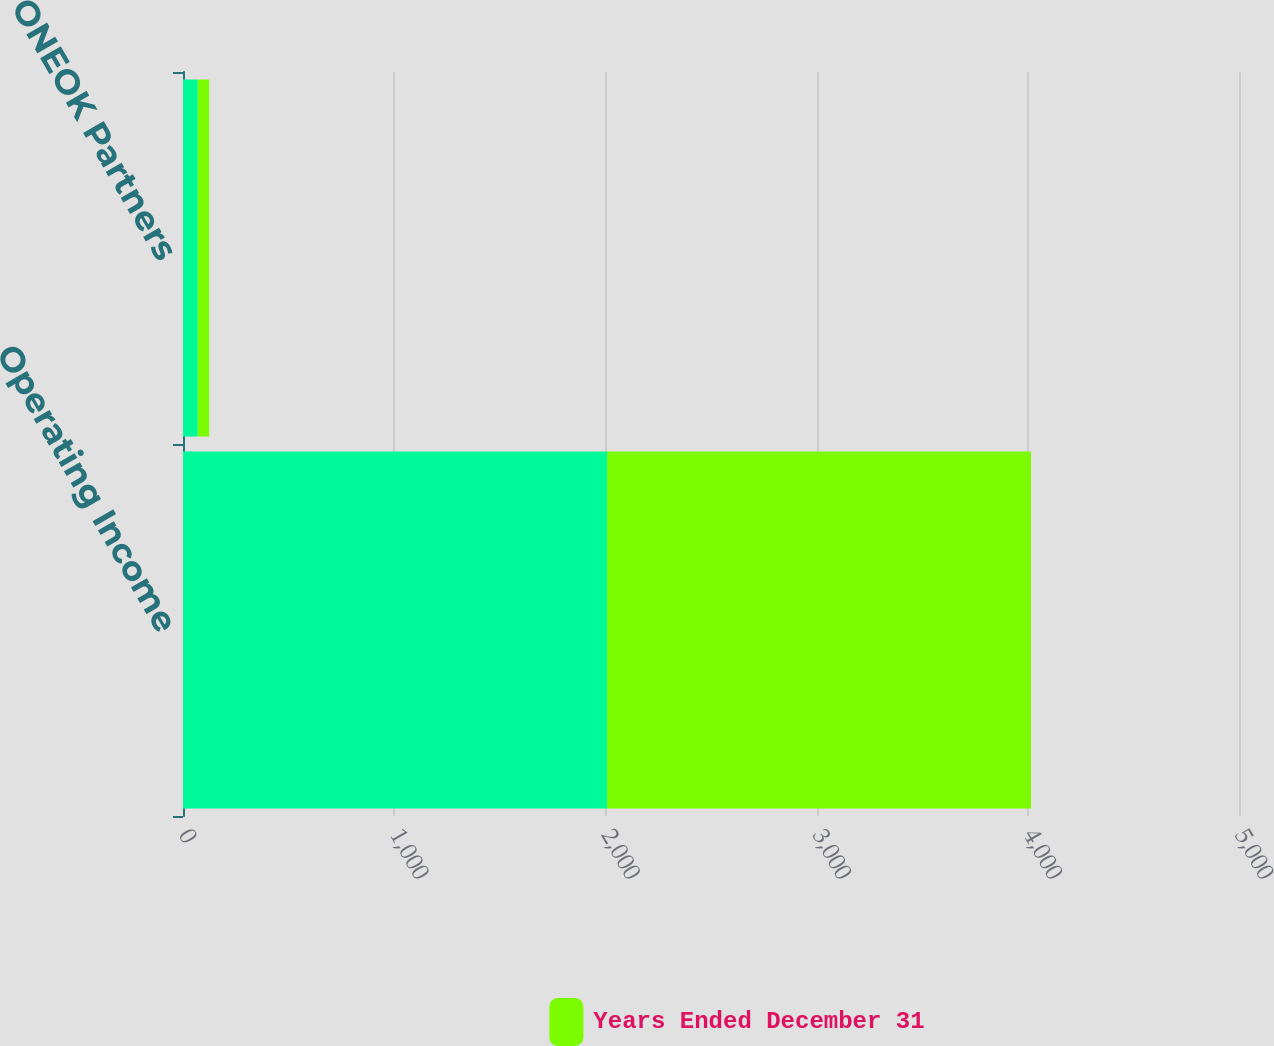<chart> <loc_0><loc_0><loc_500><loc_500><stacked_bar_chart><ecel><fcel>Operating Income<fcel>ONEOK Partners<nl><fcel>nan<fcel>2008<fcel>70<nl><fcel>Years Ended December 31<fcel>2007<fcel>54<nl></chart> 